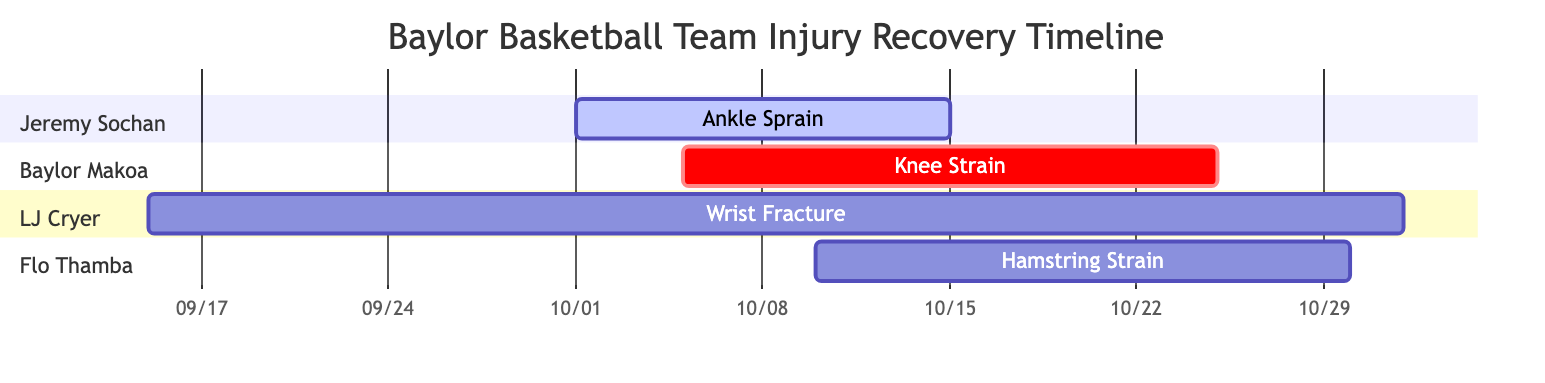What is the duration of Jeremy Sochan's injury? Jeremy Sochan's ankle sprain lasts from October 1 to October 15, which is a total of 15 days, equivalent to 2 weeks.
Answer: 2 weeks Which player has the longest recovery timeline? LJ Cryer has a wrist fracture with a recovery timeline of 6 weeks, which is longer than the other players' timelines.
Answer: LJ Cryer What start date does Flo Thamba's injury have? Flo Thamba's hamstring strain starts on October 10. This is indicated by the specific section associated with Flo Thamba in the diagram.
Answer: October 10 How many players have injuries overlapping during October? Two players, Baylor Makoa and Flo Thamba, have injuries that overlap during October, specifically from October 10 to October 25.
Answer: 2 What is the end date of Baylor Makoa's recovery? Baylor Makoa's knee strain ends on October 25, as shown in the section dedicated to his injury in the diagram.
Answer: October 25 During which period does LJ Cryer’s injury occur? LJ Cryer’s wrist fracture occurs from September 15 to November 1, capturing the timeline visually distinct from other injuries.
Answer: September 15 to November 1 Which injury has the earliest start date? The wrist fracture of LJ Cryer starts on September 15, which is earlier than any other injury displayed on the chart.
Answer: September 15 What type of injury does Flo Thamba have? Flo Thamba has a hamstring strain, as denoted clearly in the specific section of the Gantt chart.
Answer: Hamstring Strain What is the total number of injuries represented in the chart? There are a total of four different injuries listed in the chart for the basketball team.
Answer: 4 